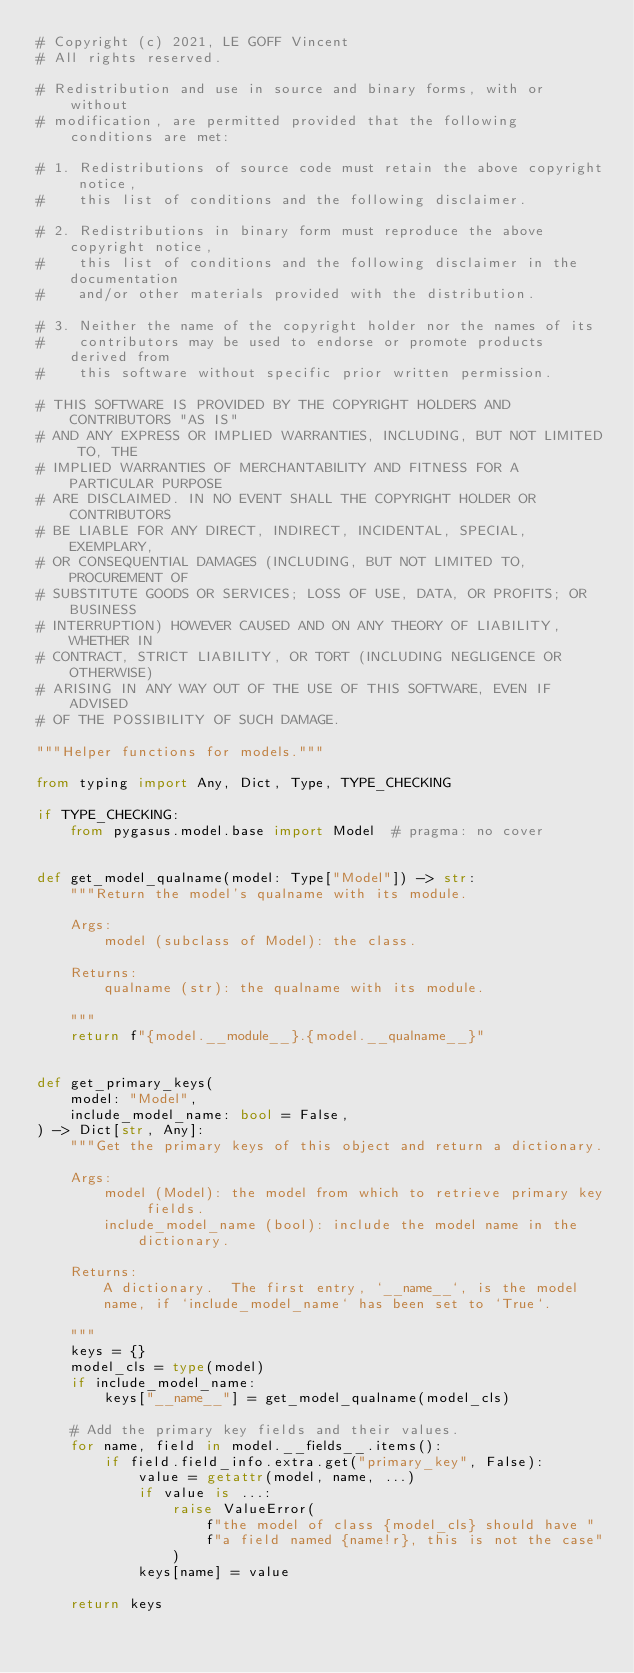<code> <loc_0><loc_0><loc_500><loc_500><_Python_># Copyright (c) 2021, LE GOFF Vincent
# All rights reserved.

# Redistribution and use in source and binary forms, with or without
# modification, are permitted provided that the following conditions are met:

# 1. Redistributions of source code must retain the above copyright notice,
#    this list of conditions and the following disclaimer.

# 2. Redistributions in binary form must reproduce the above copyright notice,
#    this list of conditions and the following disclaimer in the documentation
#    and/or other materials provided with the distribution.

# 3. Neither the name of the copyright holder nor the names of its
#    contributors may be used to endorse or promote products derived from
#    this software without specific prior written permission.

# THIS SOFTWARE IS PROVIDED BY THE COPYRIGHT HOLDERS AND CONTRIBUTORS "AS IS"
# AND ANY EXPRESS OR IMPLIED WARRANTIES, INCLUDING, BUT NOT LIMITED TO, THE
# IMPLIED WARRANTIES OF MERCHANTABILITY AND FITNESS FOR A PARTICULAR PURPOSE
# ARE DISCLAIMED. IN NO EVENT SHALL THE COPYRIGHT HOLDER OR CONTRIBUTORS
# BE LIABLE FOR ANY DIRECT, INDIRECT, INCIDENTAL, SPECIAL, EXEMPLARY,
# OR CONSEQUENTIAL DAMAGES (INCLUDING, BUT NOT LIMITED TO, PROCUREMENT OF
# SUBSTITUTE GOODS OR SERVICES; LOSS OF USE, DATA, OR PROFITS; OR BUSINESS
# INTERRUPTION) HOWEVER CAUSED AND ON ANY THEORY OF LIABILITY, WHETHER IN
# CONTRACT, STRICT LIABILITY, OR TORT (INCLUDING NEGLIGENCE OR OTHERWISE)
# ARISING IN ANY WAY OUT OF THE USE OF THIS SOFTWARE, EVEN IF ADVISED
# OF THE POSSIBILITY OF SUCH DAMAGE.

"""Helper functions for models."""

from typing import Any, Dict, Type, TYPE_CHECKING

if TYPE_CHECKING:
    from pygasus.model.base import Model  # pragma: no cover


def get_model_qualname(model: Type["Model"]) -> str:
    """Return the model's qualname with its module.

    Args:
        model (subclass of Model): the class.

    Returns:
        qualname (str): the qualname with its module.

    """
    return f"{model.__module__}.{model.__qualname__}"


def get_primary_keys(
    model: "Model",
    include_model_name: bool = False,
) -> Dict[str, Any]:
    """Get the primary keys of this object and return a dictionary.

    Args:
        model (Model): the model from which to retrieve primary key fields.
        include_model_name (bool): include the model name in the dictionary.

    Returns:
        A dictionary.  The first entry, `__name__`, is the model
        name, if `include_model_name` has been set to `True`.

    """
    keys = {}
    model_cls = type(model)
    if include_model_name:
        keys["__name__"] = get_model_qualname(model_cls)

    # Add the primary key fields and their values.
    for name, field in model.__fields__.items():
        if field.field_info.extra.get("primary_key", False):
            value = getattr(model, name, ...)
            if value is ...:
                raise ValueError(
                    f"the model of class {model_cls} should have "
                    f"a field named {name!r}, this is not the case"
                )
            keys[name] = value

    return keys
</code> 